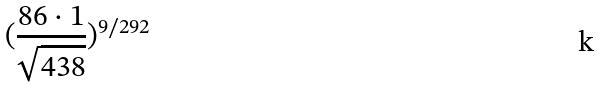Convert formula to latex. <formula><loc_0><loc_0><loc_500><loc_500>( \frac { 8 6 \cdot 1 } { \sqrt { 4 3 8 } } ) ^ { 9 / 2 9 2 }</formula> 